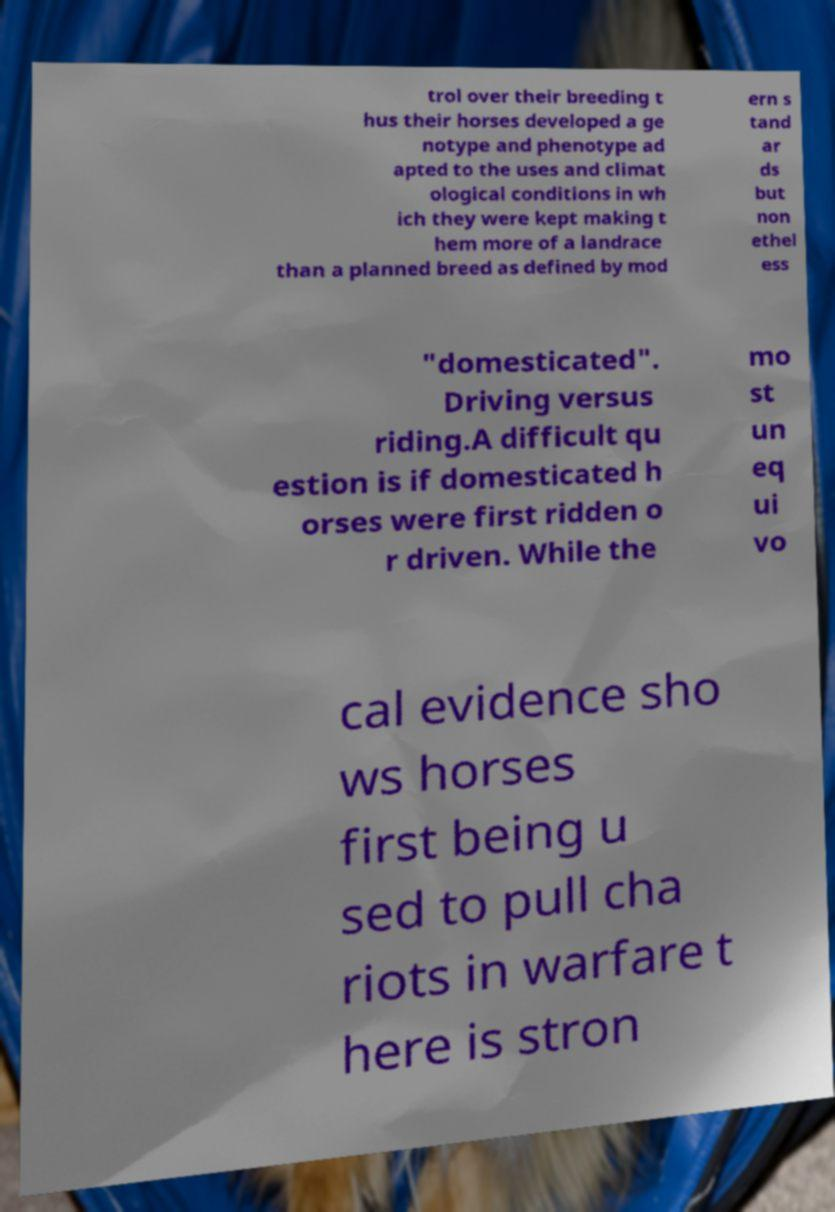What messages or text are displayed in this image? I need them in a readable, typed format. trol over their breeding t hus their horses developed a ge notype and phenotype ad apted to the uses and climat ological conditions in wh ich they were kept making t hem more of a landrace than a planned breed as defined by mod ern s tand ar ds but non ethel ess "domesticated". Driving versus riding.A difficult qu estion is if domesticated h orses were first ridden o r driven. While the mo st un eq ui vo cal evidence sho ws horses first being u sed to pull cha riots in warfare t here is stron 